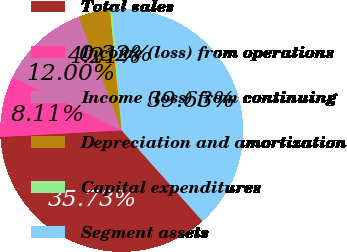<chart> <loc_0><loc_0><loc_500><loc_500><pie_chart><fcel>Total sales<fcel>Income (loss) from operations<fcel>Income (loss) from continuing<fcel>Depreciation and amortization<fcel>Capital expenditures<fcel>Segment assets<nl><fcel>35.73%<fcel>8.11%<fcel>12.0%<fcel>4.21%<fcel>0.32%<fcel>39.63%<nl></chart> 